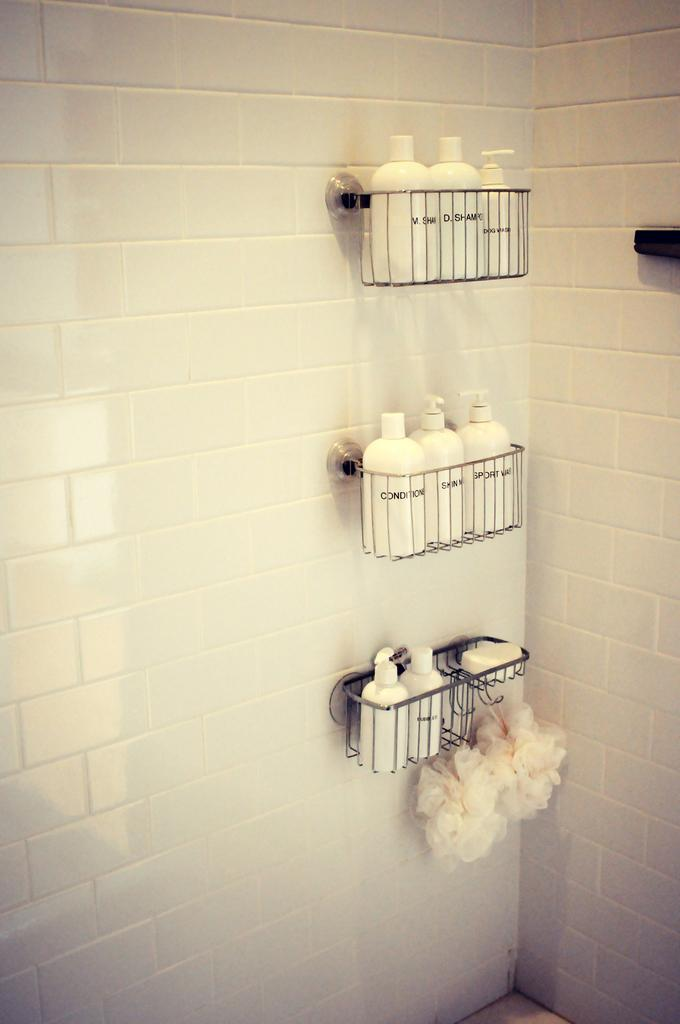What is the main feature of the image? There is a wall in the image. What color is the wall? The wall is white in color. What objects are attached to the wall? There are metal baskets attached to the wall. What can be found inside the metal baskets? There are bottles in the metal baskets. What cleaning tool is visible in the image? There is a scrubber visible in the image. How many clocks are hanging on the wall in the image? There are no clocks visible in the image; it only features a white wall with metal baskets and bottles. What type of meat is being stored in the metal baskets? There is no meat present in the image; the metal baskets contain bottles. 